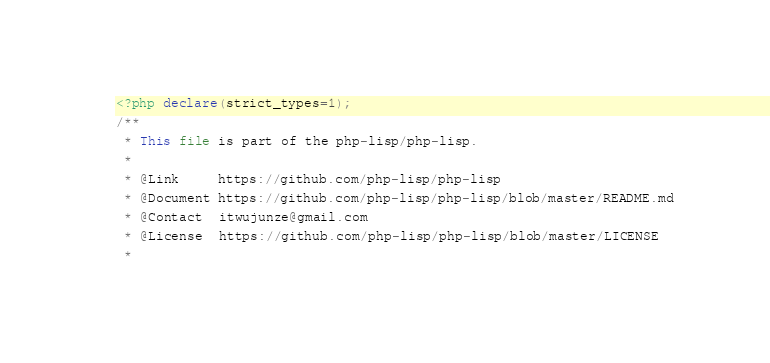Convert code to text. <code><loc_0><loc_0><loc_500><loc_500><_PHP_><?php declare(strict_types=1);
/**
 * This file is part of the php-lisp/php-lisp.
 *
 * @Link     https://github.com/php-lisp/php-lisp
 * @Document https://github.com/php-lisp/php-lisp/blob/master/README.md
 * @Contact  itwujunze@gmail.com
 * @License  https://github.com/php-lisp/php-lisp/blob/master/LICENSE
 *</code> 